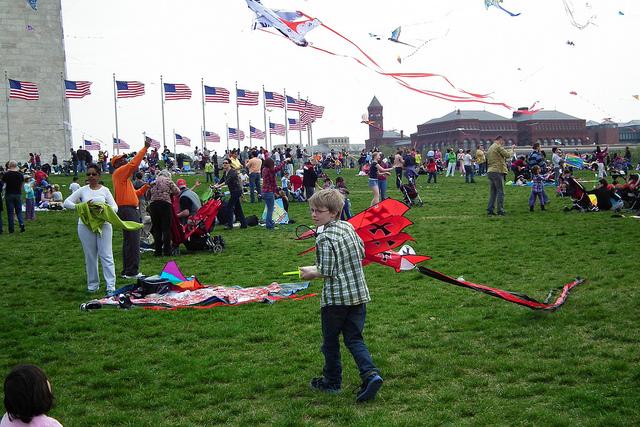What monument is in this photo?
Write a very short answer. Washington. What is the theme of the blonde boys kite?
Write a very short answer. Red baron. Are these all American flags?
Answer briefly. Yes. What two colors make up the boy's kite?
Write a very short answer. Red black. Is this a riding tournament?
Short answer required. No. 